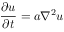Convert formula to latex. <formula><loc_0><loc_0><loc_500><loc_500>{ \frac { \partial u } { \partial t } } = a \nabla ^ { 2 } u</formula> 